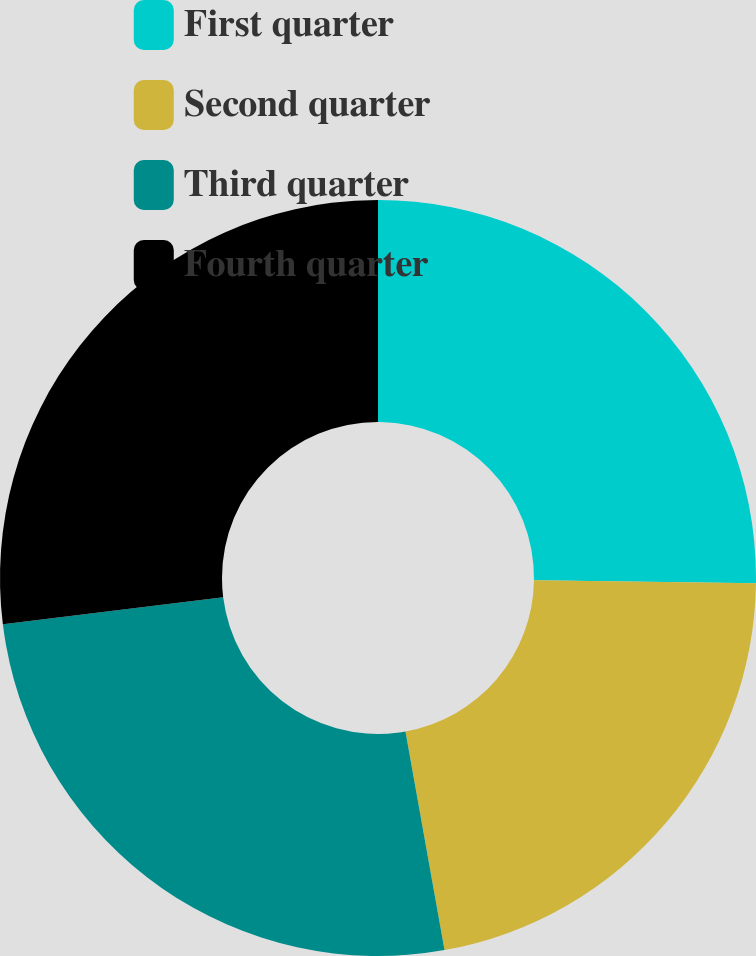<chart> <loc_0><loc_0><loc_500><loc_500><pie_chart><fcel>First quarter<fcel>Second quarter<fcel>Third quarter<fcel>Fourth quarter<nl><fcel>25.22%<fcel>21.97%<fcel>25.86%<fcel>26.96%<nl></chart> 